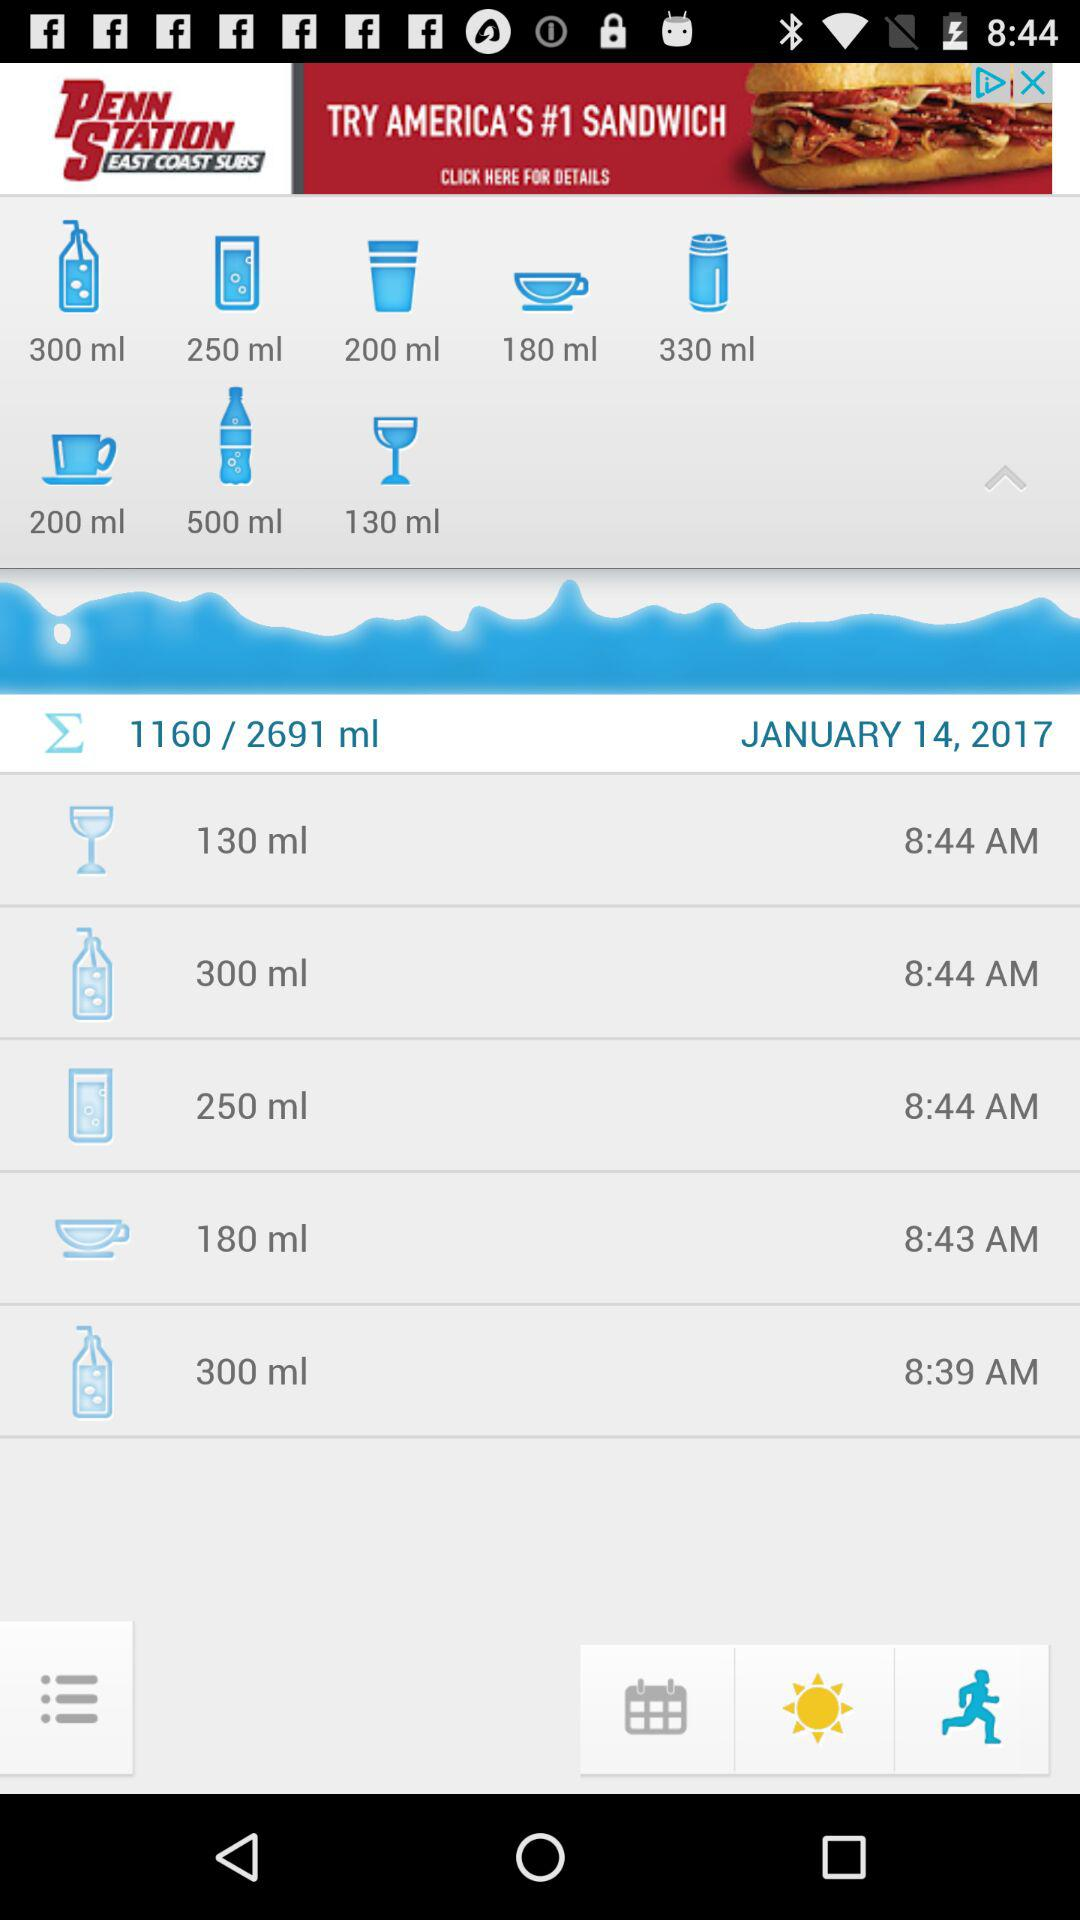What's the date showing on the screen? The date is January 14, 2017. 